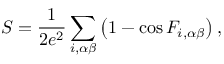Convert formula to latex. <formula><loc_0><loc_0><loc_500><loc_500>S = \frac { 1 } { 2 e ^ { 2 } } \sum _ { i , \alpha \beta } \left ( 1 - \cos F _ { i , \alpha \beta } \right ) ,</formula> 